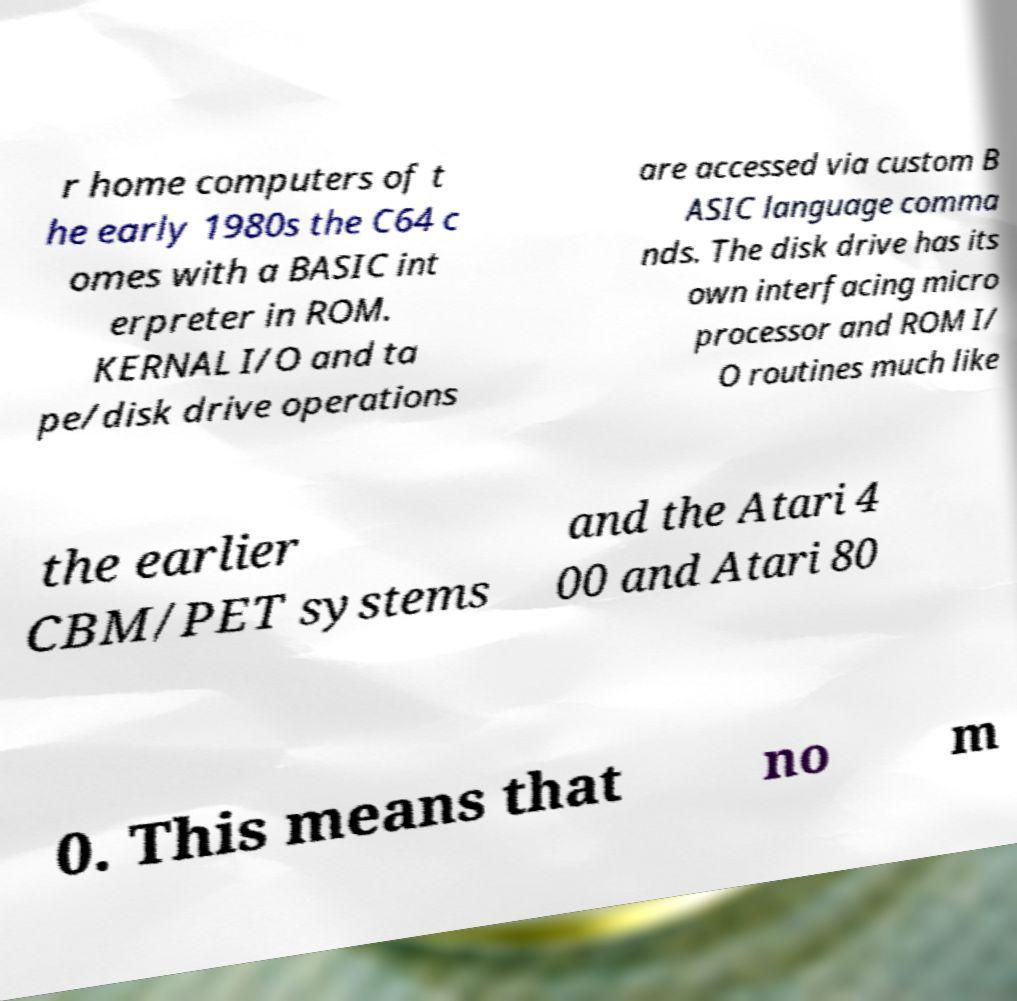Can you accurately transcribe the text from the provided image for me? r home computers of t he early 1980s the C64 c omes with a BASIC int erpreter in ROM. KERNAL I/O and ta pe/disk drive operations are accessed via custom B ASIC language comma nds. The disk drive has its own interfacing micro processor and ROM I/ O routines much like the earlier CBM/PET systems and the Atari 4 00 and Atari 80 0. This means that no m 